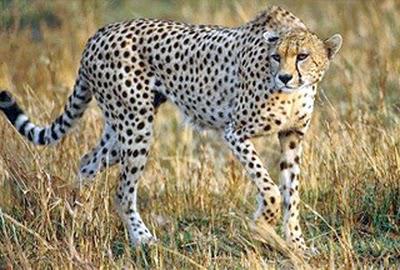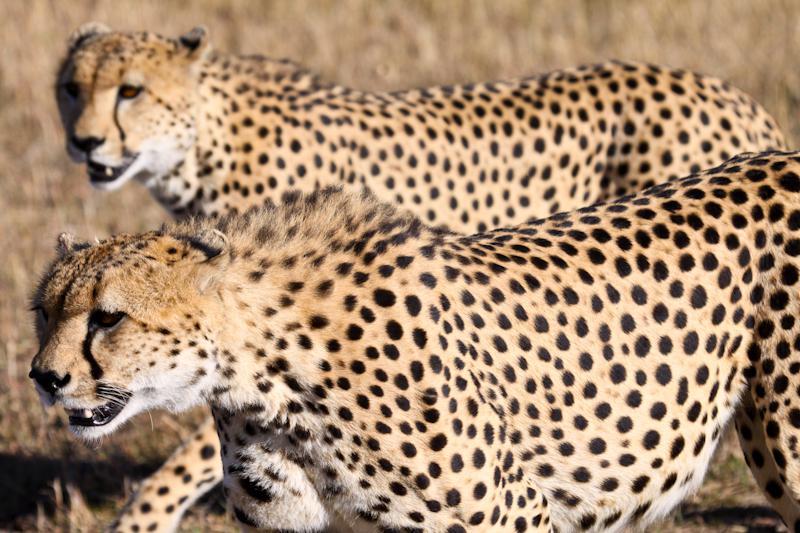The first image is the image on the left, the second image is the image on the right. Examine the images to the left and right. Is the description "in the left image cheetahs are laying on a mound of dirt" accurate? Answer yes or no. No. The first image is the image on the left, the second image is the image on the right. Examine the images to the left and right. Is the description "In one image, there are three cheetahs sitting on their haunches, and in the other image, there are at least three cheetahs lying down." accurate? Answer yes or no. No. 